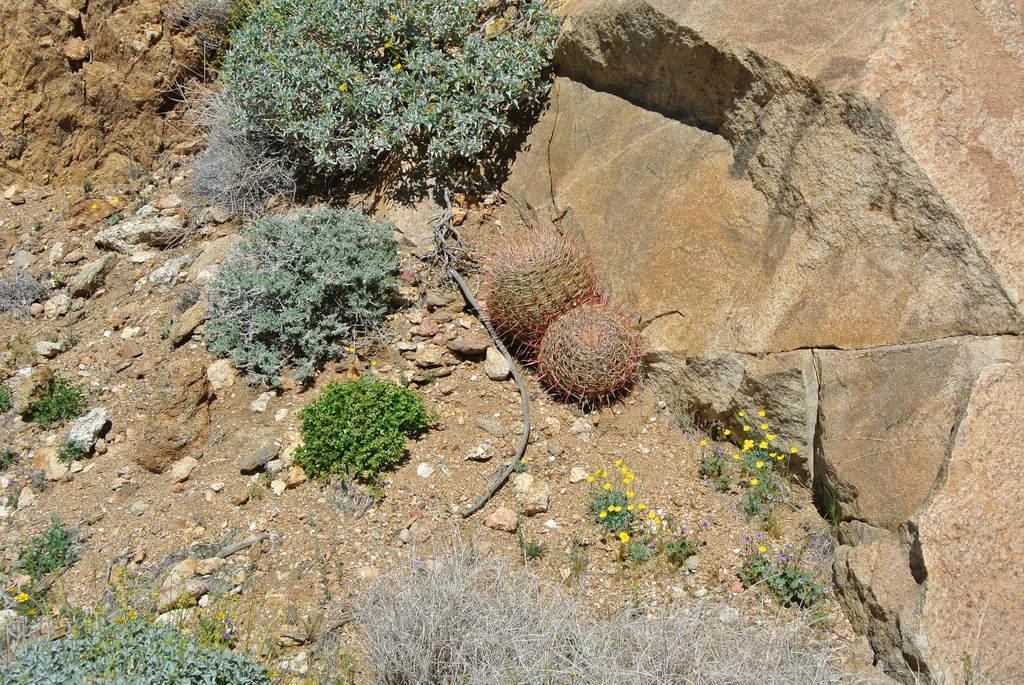What type of natural elements can be seen in the image? There are stones, grass, bushes, and flowers in the image. Can you describe the vegetation in the image? The image contains grass, bushes, and flowers. What else is present on the ground in the image? There are other things on the ground in the image, but the specifics are not mentioned in the facts. How many trucks are parked next to the flowers in the image? There are no trucks present in the image; it only contains stones, grass, bushes, and flowers. Can you tell me the color of the glove that is being used to join the flowers together? There is no glove or any indication of joining the flowers in the image. 